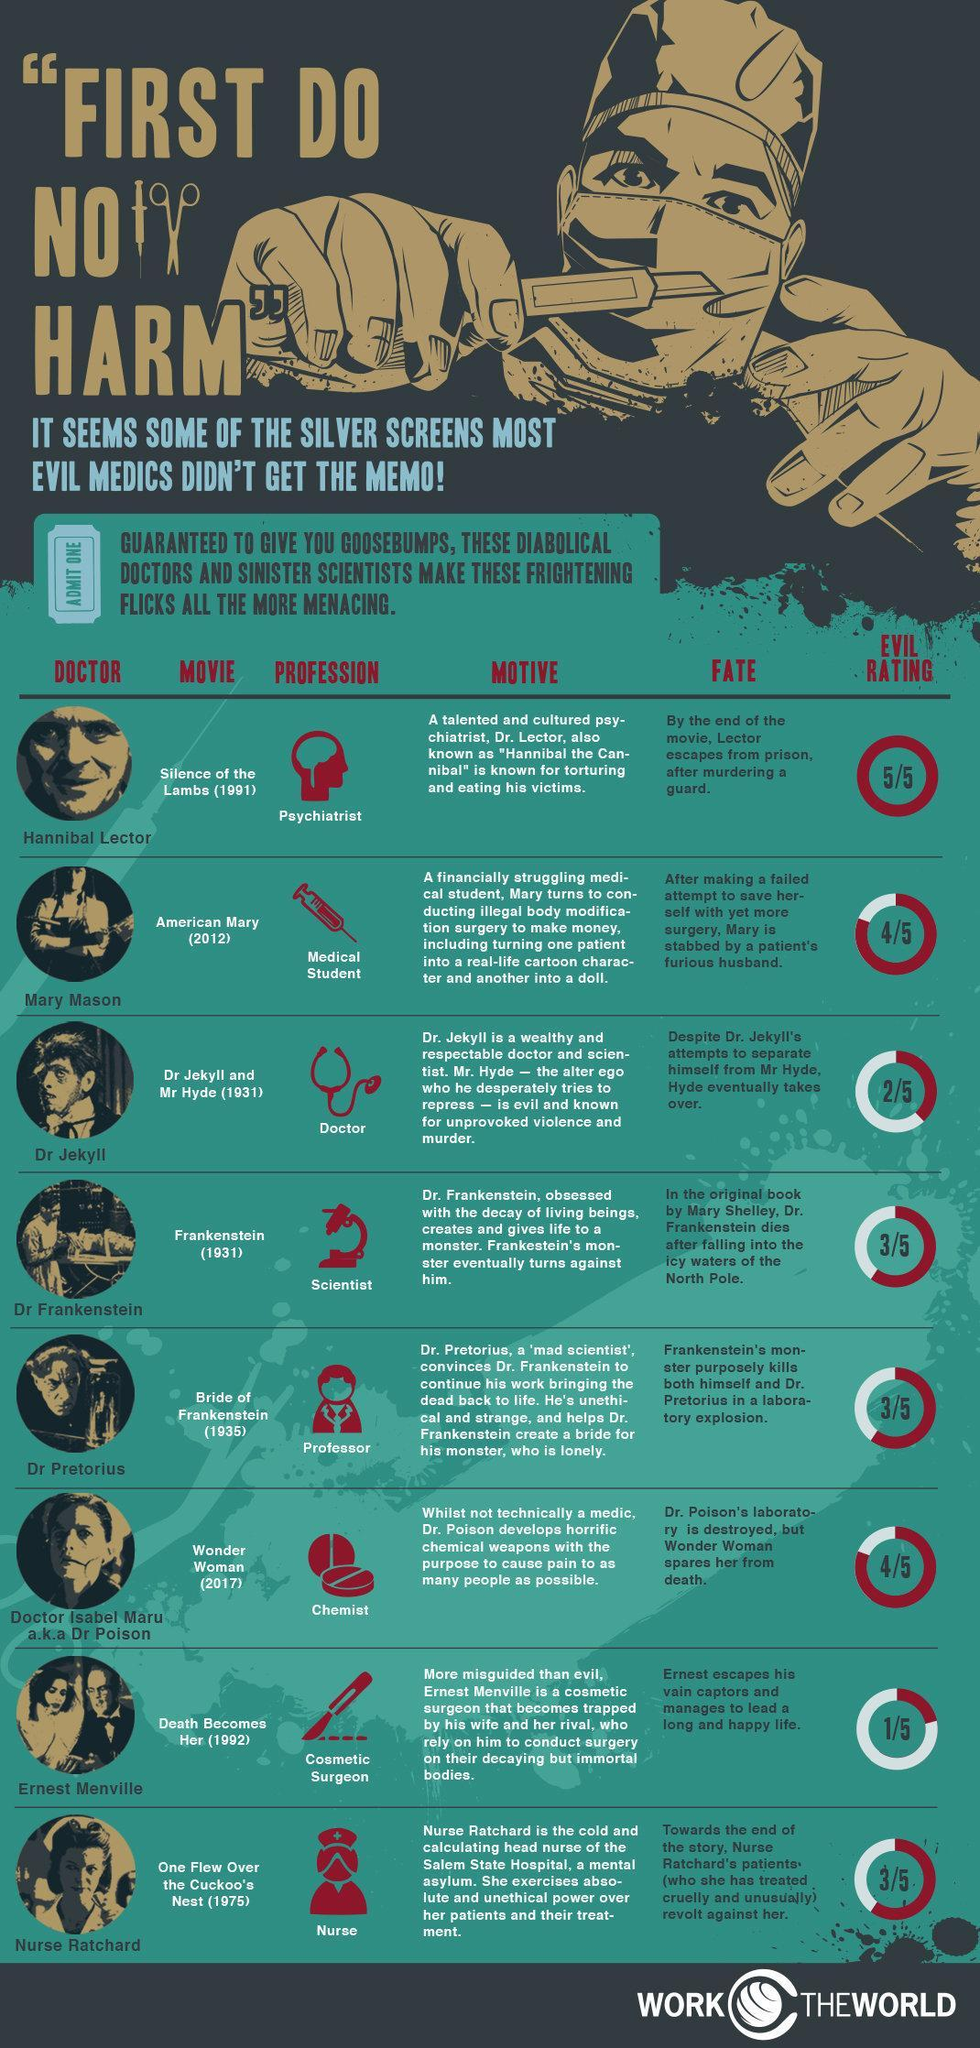What is the role play name of professor in the movie 'Bride of Frankenstein'?
Answer the question with a short phrase. Dr Pretorius What is the role play name of medical student in the movie 'American Mary'? Mary Mason What is the evil rating given for the movie 'Wonder Women'? 4/5 What is the evil rating given for the movie 'American Mary'? 4/5 What is the role play name of Cosmetic Surgeon in the movie 'Death Becomes Her'? Ernest Menville When was the movie 'Wonder Woman' released? 2017 When was the movie 'Frankenstein' released? (1931) 